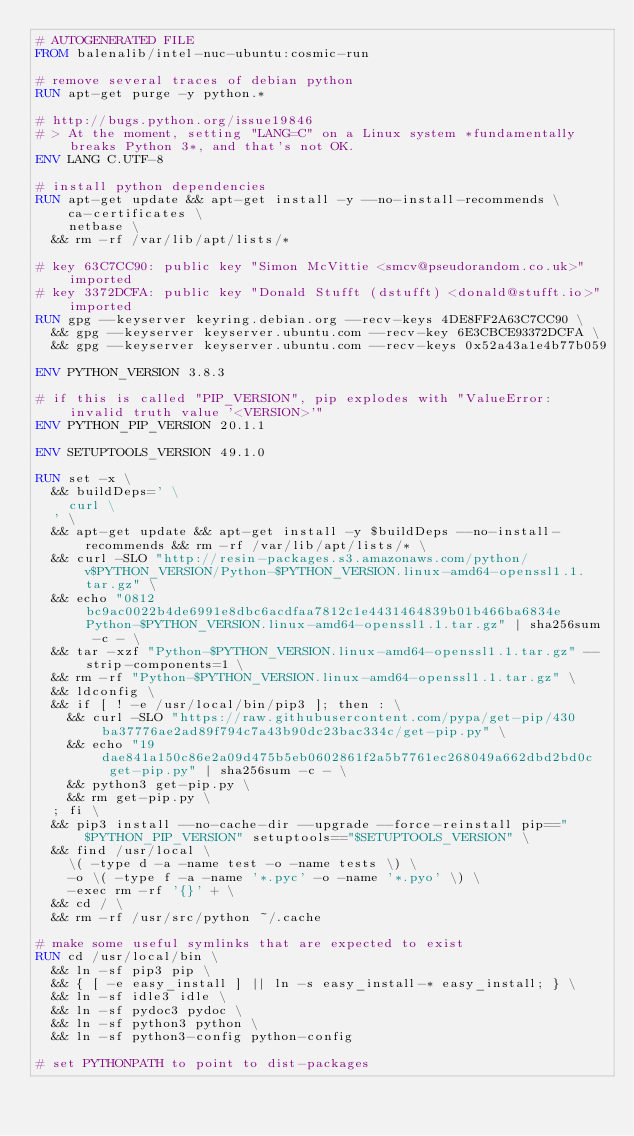<code> <loc_0><loc_0><loc_500><loc_500><_Dockerfile_># AUTOGENERATED FILE
FROM balenalib/intel-nuc-ubuntu:cosmic-run

# remove several traces of debian python
RUN apt-get purge -y python.*

# http://bugs.python.org/issue19846
# > At the moment, setting "LANG=C" on a Linux system *fundamentally breaks Python 3*, and that's not OK.
ENV LANG C.UTF-8

# install python dependencies
RUN apt-get update && apt-get install -y --no-install-recommends \
		ca-certificates \
		netbase \
	&& rm -rf /var/lib/apt/lists/*

# key 63C7CC90: public key "Simon McVittie <smcv@pseudorandom.co.uk>" imported
# key 3372DCFA: public key "Donald Stufft (dstufft) <donald@stufft.io>" imported
RUN gpg --keyserver keyring.debian.org --recv-keys 4DE8FF2A63C7CC90 \
	&& gpg --keyserver keyserver.ubuntu.com --recv-key 6E3CBCE93372DCFA \
	&& gpg --keyserver keyserver.ubuntu.com --recv-keys 0x52a43a1e4b77b059

ENV PYTHON_VERSION 3.8.3

# if this is called "PIP_VERSION", pip explodes with "ValueError: invalid truth value '<VERSION>'"
ENV PYTHON_PIP_VERSION 20.1.1

ENV SETUPTOOLS_VERSION 49.1.0

RUN set -x \
	&& buildDeps=' \
		curl \
	' \
	&& apt-get update && apt-get install -y $buildDeps --no-install-recommends && rm -rf /var/lib/apt/lists/* \
	&& curl -SLO "http://resin-packages.s3.amazonaws.com/python/v$PYTHON_VERSION/Python-$PYTHON_VERSION.linux-amd64-openssl1.1.tar.gz" \
	&& echo "0812bc9ac0022b4de6991e8dbc6acdfaa7812c1e4431464839b01b466ba6834e  Python-$PYTHON_VERSION.linux-amd64-openssl1.1.tar.gz" | sha256sum -c - \
	&& tar -xzf "Python-$PYTHON_VERSION.linux-amd64-openssl1.1.tar.gz" --strip-components=1 \
	&& rm -rf "Python-$PYTHON_VERSION.linux-amd64-openssl1.1.tar.gz" \
	&& ldconfig \
	&& if [ ! -e /usr/local/bin/pip3 ]; then : \
		&& curl -SLO "https://raw.githubusercontent.com/pypa/get-pip/430ba37776ae2ad89f794c7a43b90dc23bac334c/get-pip.py" \
		&& echo "19dae841a150c86e2a09d475b5eb0602861f2a5b7761ec268049a662dbd2bd0c  get-pip.py" | sha256sum -c - \
		&& python3 get-pip.py \
		&& rm get-pip.py \
	; fi \
	&& pip3 install --no-cache-dir --upgrade --force-reinstall pip=="$PYTHON_PIP_VERSION" setuptools=="$SETUPTOOLS_VERSION" \
	&& find /usr/local \
		\( -type d -a -name test -o -name tests \) \
		-o \( -type f -a -name '*.pyc' -o -name '*.pyo' \) \
		-exec rm -rf '{}' + \
	&& cd / \
	&& rm -rf /usr/src/python ~/.cache

# make some useful symlinks that are expected to exist
RUN cd /usr/local/bin \
	&& ln -sf pip3 pip \
	&& { [ -e easy_install ] || ln -s easy_install-* easy_install; } \
	&& ln -sf idle3 idle \
	&& ln -sf pydoc3 pydoc \
	&& ln -sf python3 python \
	&& ln -sf python3-config python-config

# set PYTHONPATH to point to dist-packages</code> 